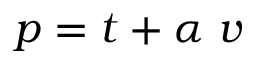Convert formula to latex. <formula><loc_0><loc_0><loc_500><loc_500>p = t + \alpha \ v</formula> 